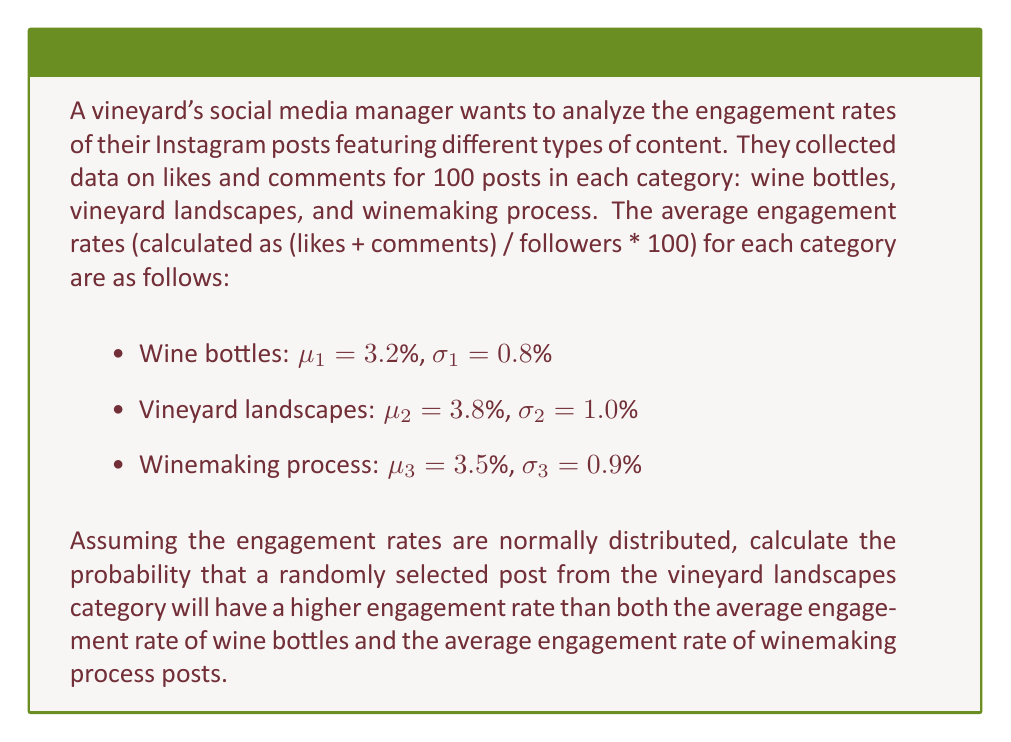Can you answer this question? To solve this problem, we need to follow these steps:

1. Identify the distribution of vineyard landscape post engagement rates.
2. Calculate the z-score for the point where the vineyard landscape engagement rate equals the higher of the two other category averages.
3. Use the standard normal distribution to find the probability.

Step 1: The vineyard landscape posts have a normal distribution with $\mu_2 = 3.8\%$ and $\sigma_2 = 1.0\%$.

Step 2: We need to compare the vineyard landscape engagement rate to the higher of the other two averages, which is the winemaking process at 3.5%.

Calculate the z-score:

$$z = \frac{x - \mu}{\sigma} = \frac{3.5\% - 3.8\%}{1.0\%} = -0.3$$

Step 3: We want the probability that a vineyard landscape post has an engagement rate higher than 3.5%, which is equivalent to the area to the right of z = -0.3 on the standard normal distribution.

Using a standard normal distribution table or calculator, we find:

$$P(Z > -0.3) = 1 - P(Z < -0.3) = 1 - 0.3821 = 0.6179$$

Therefore, the probability that a randomly selected vineyard landscape post will have a higher engagement rate than both the average of wine bottle posts and the average of winemaking process posts is approximately 0.6179 or 61.79%.
Answer: 0.6179 or 61.79% 